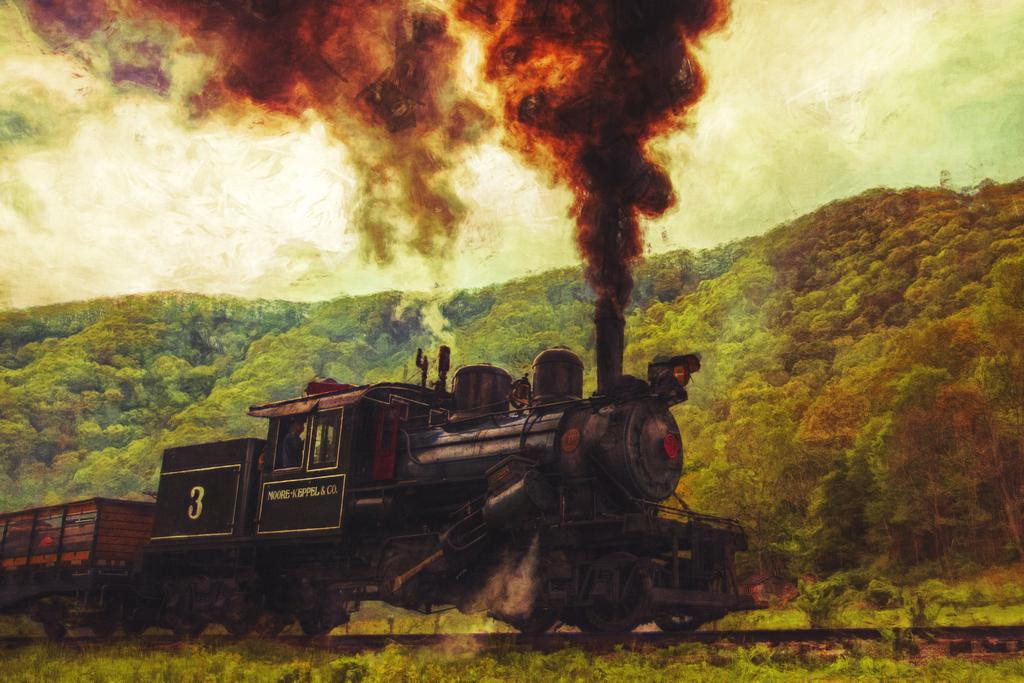What is the main subject of the image? The main subject of the image is a train. Where is the train located in the image? The train is on a railway-track in the image. What colors can be seen on the train? The train is black and brown in color. What can be seen in the background of the image? There are trees and the sky visible in the image. Can you tell me how many plates are stacked on the train in the image? There are no plates present in the image; it features a train on a railway-track. What type of pin is holding the train to the track in the image? There is no pin holding the train to the track in the image; the train is on a railway-track. 